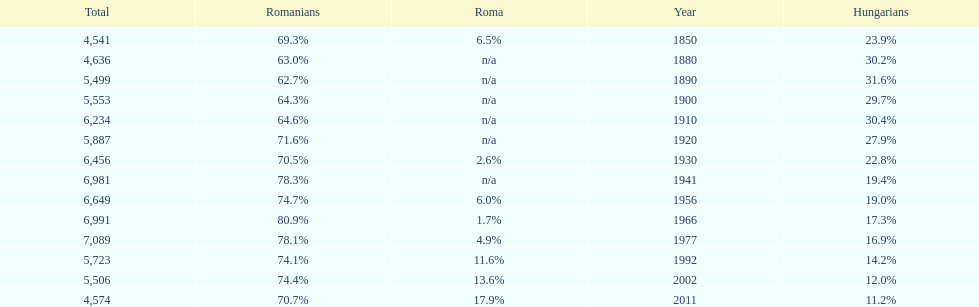Which year precedes the one with a 7 1977. 